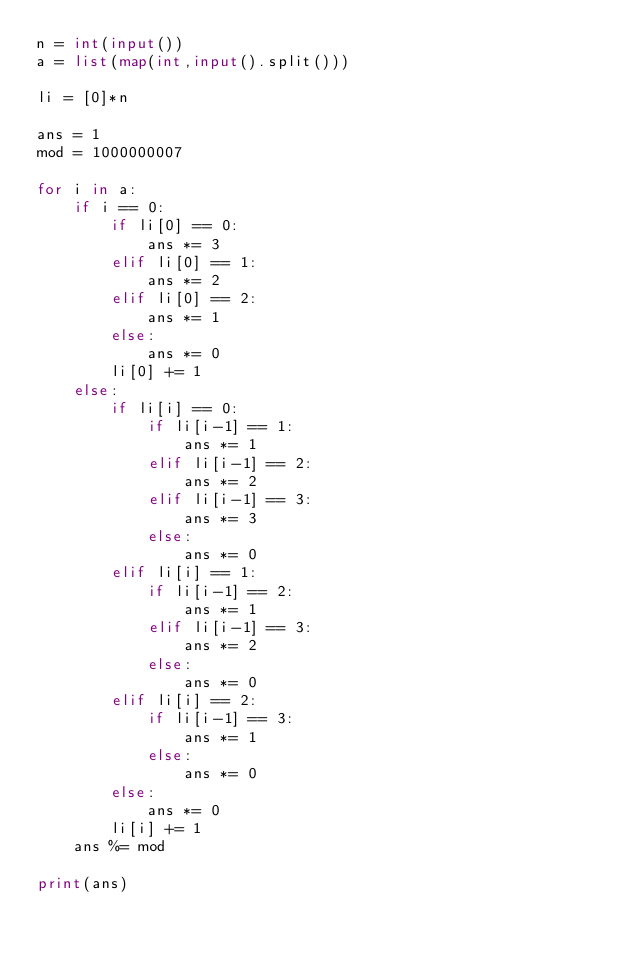Convert code to text. <code><loc_0><loc_0><loc_500><loc_500><_Python_>n = int(input())
a = list(map(int,input().split()))

li = [0]*n

ans = 1
mod = 1000000007

for i in a:
    if i == 0:
        if li[0] == 0:
            ans *= 3
        elif li[0] == 1:
            ans *= 2
        elif li[0] == 2:
            ans *= 1
        else:
            ans *= 0
        li[0] += 1
    else:
        if li[i] == 0:
            if li[i-1] == 1:
                ans *= 1
            elif li[i-1] == 2:
                ans *= 2
            elif li[i-1] == 3:
                ans *= 3
            else:
                ans *= 0
        elif li[i] == 1:
            if li[i-1] == 2:
                ans *= 1
            elif li[i-1] == 3:
                ans *= 2
            else:
                ans *= 0
        elif li[i] == 2:
            if li[i-1] == 3:
                ans *= 1
            else:
                ans *= 0
        else:
            ans *= 0
        li[i] += 1
    ans %= mod

print(ans)
</code> 